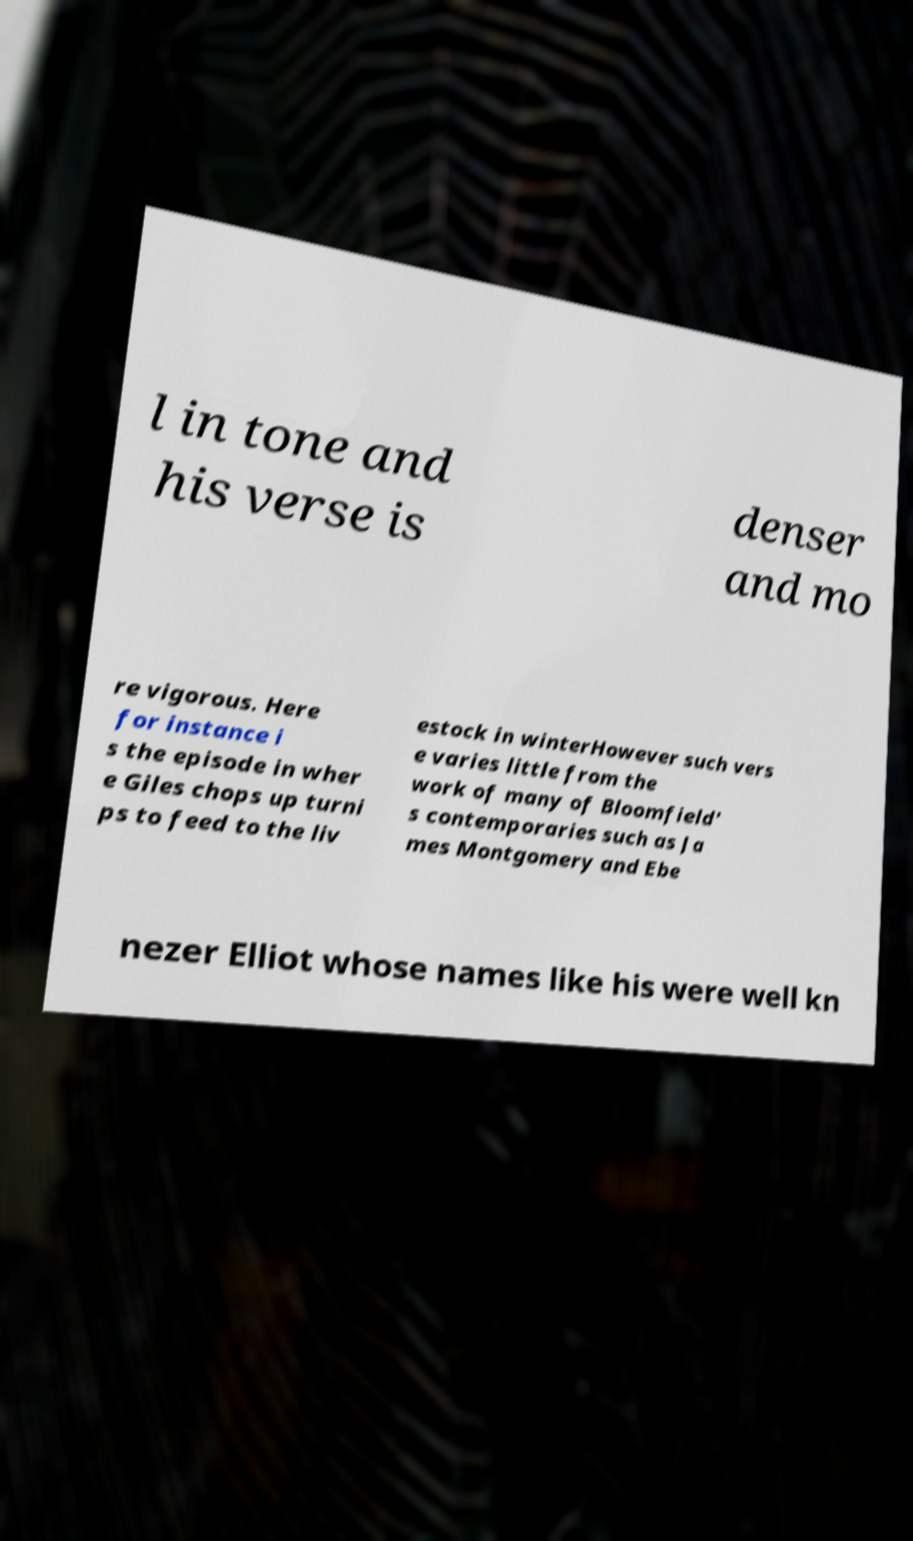Could you assist in decoding the text presented in this image and type it out clearly? l in tone and his verse is denser and mo re vigorous. Here for instance i s the episode in wher e Giles chops up turni ps to feed to the liv estock in winterHowever such vers e varies little from the work of many of Bloomfield' s contemporaries such as Ja mes Montgomery and Ebe nezer Elliot whose names like his were well kn 